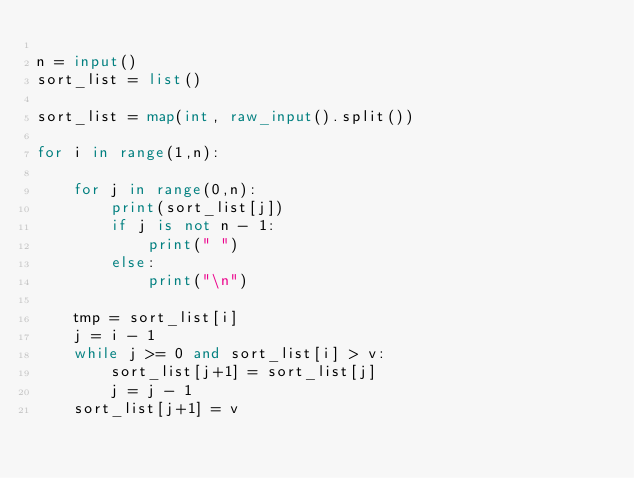Convert code to text. <code><loc_0><loc_0><loc_500><loc_500><_Python_>
n = input()
sort_list = list()

sort_list = map(int, raw_input().split())

for i in range(1,n):
    
    for j in range(0,n):
        print(sort_list[j])
        if j is not n - 1:
            print(" ")
        else:
            print("\n")
    
    tmp = sort_list[i]
    j = i - 1
    while j >= 0 and sort_list[i] > v:
        sort_list[j+1] = sort_list[j]
        j = j - 1
    sort_list[j+1] = v


</code> 